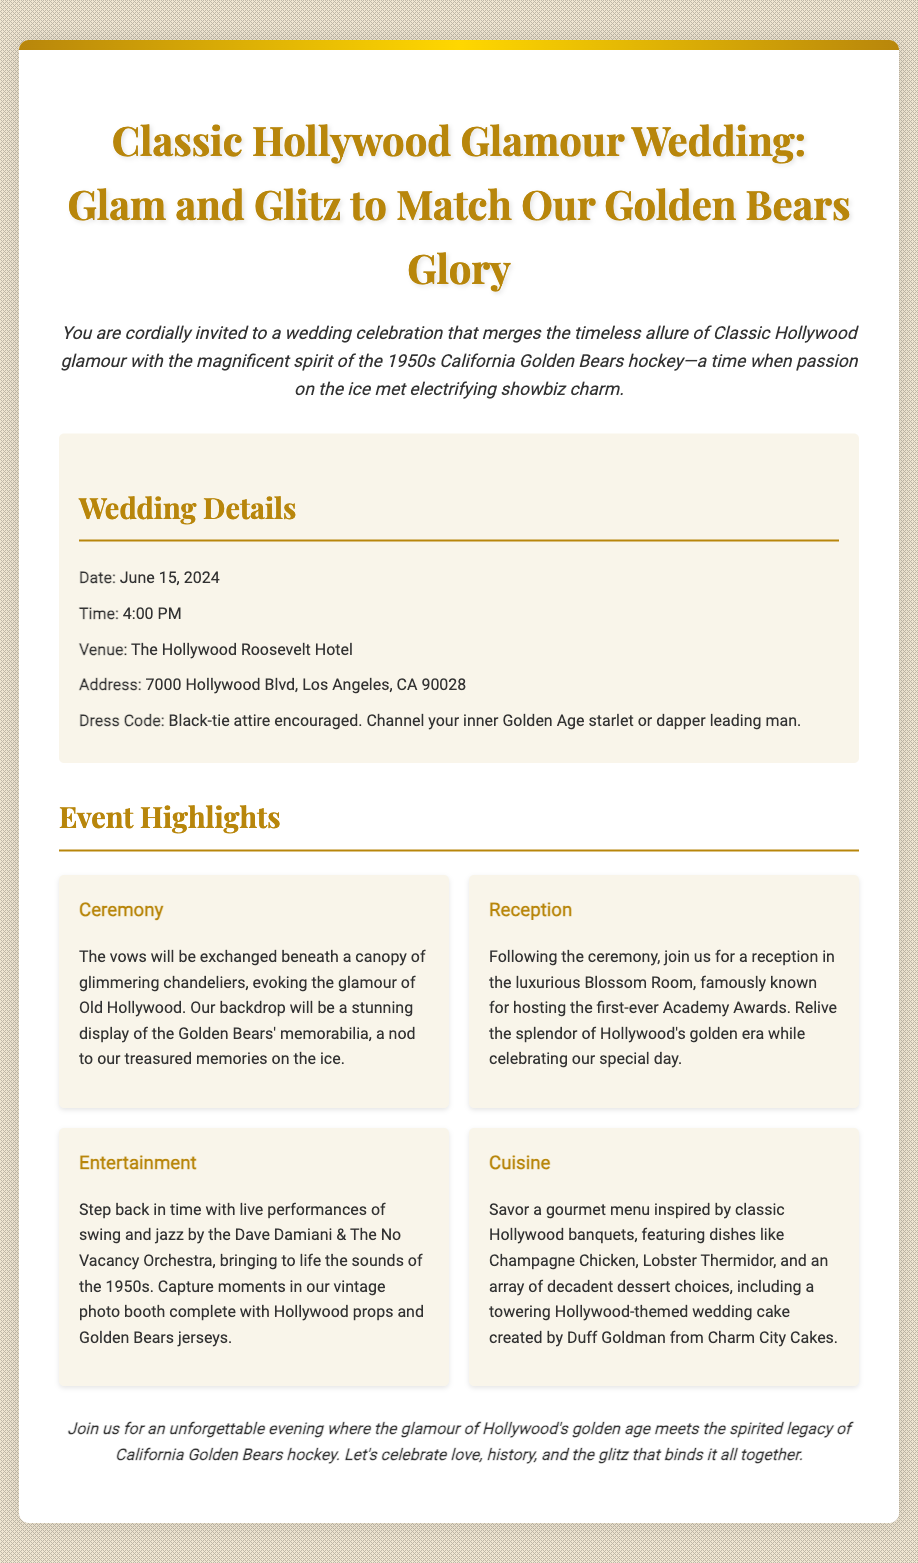What is the date of the wedding? The document specifies June 15, 2024, as the wedding date.
Answer: June 15, 2024 What is the venue for the wedding? The venue mentioned in the document is The Hollywood Roosevelt Hotel.
Answer: The Hollywood Roosevelt Hotel What time does the wedding start? The starting time for the wedding is listed as 4:00 PM.
Answer: 4:00 PM What is encouraged as the dress code? The invitation encourages guests to wear black-tie attire.
Answer: Black-tie attire What notable room is the reception held in? The reception takes place in the Blossom Room, known for its historical significance.
Answer: Blossom Room Which orchestra will perform live at the event? The document mentions Dave Damiani & The No Vacancy Orchestra for live performances.
Answer: Dave Damiani & The No Vacancy Orchestra What type of cuisine will be served? The menu features a gourmet selection inspired by classic Hollywood banquets.
Answer: Gourmet menu inspired by classic Hollywood banquets What kind of photo booth will be available? A vintage photo booth complete with Hollywood props and Golden Bears jerseys will be featured.
Answer: Vintage photo booth What theme does the wedding combine? The wedding combines Classic Hollywood glamour with the spirit of the California Golden Bears hockey.
Answer: Classic Hollywood glamour and California Golden Bears hockey 